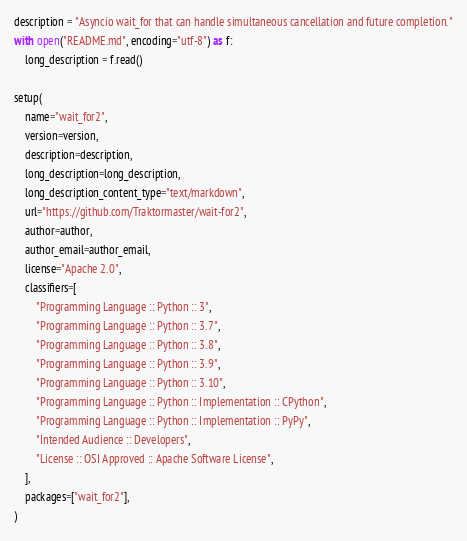<code> <loc_0><loc_0><loc_500><loc_500><_Python_>

description = "Asyncio wait_for that can handle simultaneous cancellation and future completion."
with open("README.md", encoding="utf-8") as f:
    long_description = f.read()

setup(
    name="wait_for2",
    version=version,
    description=description,
    long_description=long_description,
    long_description_content_type="text/markdown",
    url="https://github.com/Traktormaster/wait-for2",
    author=author,
    author_email=author_email,
    license="Apache 2.0",
    classifiers=[
        "Programming Language :: Python :: 3",
        "Programming Language :: Python :: 3.7",
        "Programming Language :: Python :: 3.8",
        "Programming Language :: Python :: 3.9",
        "Programming Language :: Python :: 3.10",
        "Programming Language :: Python :: Implementation :: CPython",
        "Programming Language :: Python :: Implementation :: PyPy",
        "Intended Audience :: Developers",
        "License :: OSI Approved :: Apache Software License",
    ],
    packages=["wait_for2"],
)
</code> 